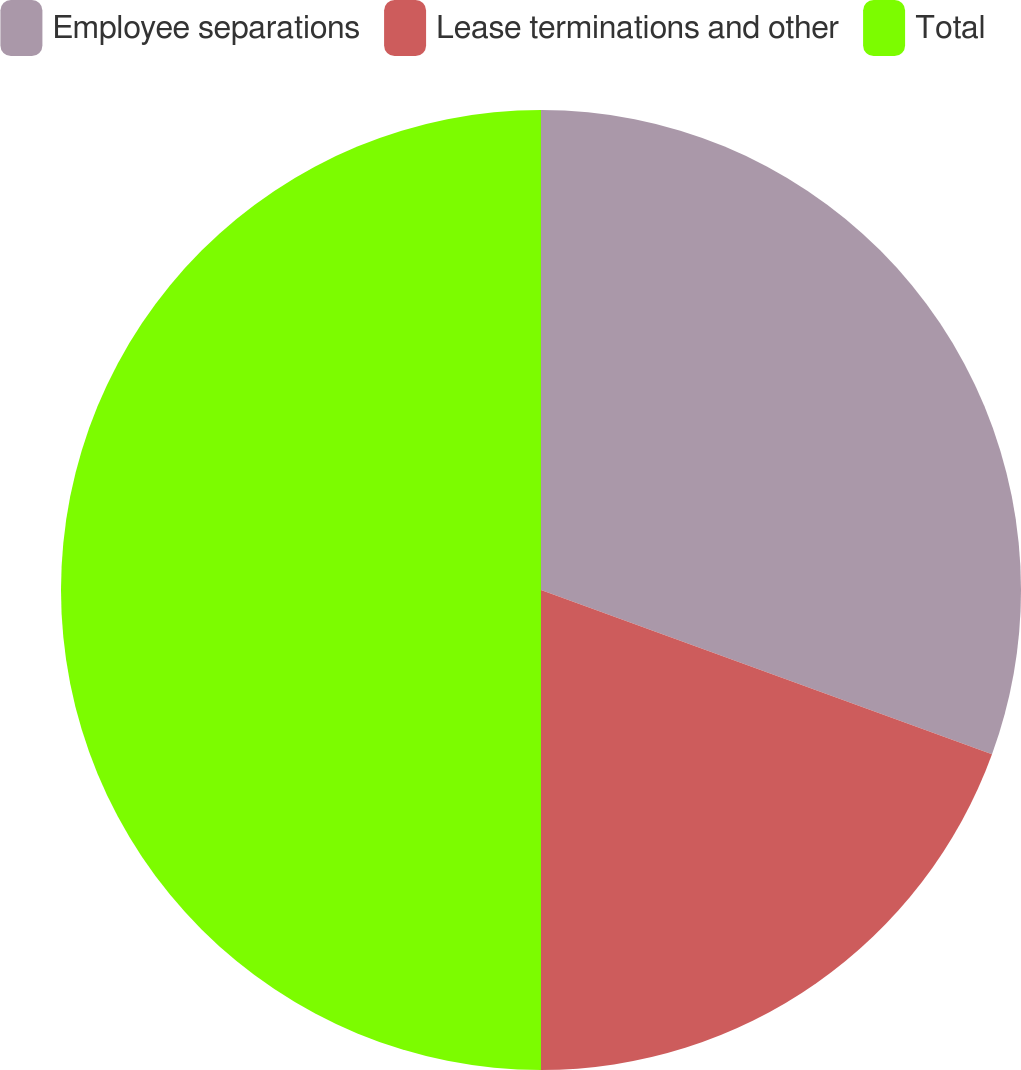Convert chart. <chart><loc_0><loc_0><loc_500><loc_500><pie_chart><fcel>Employee separations<fcel>Lease terminations and other<fcel>Total<nl><fcel>30.56%<fcel>19.44%<fcel>50.0%<nl></chart> 